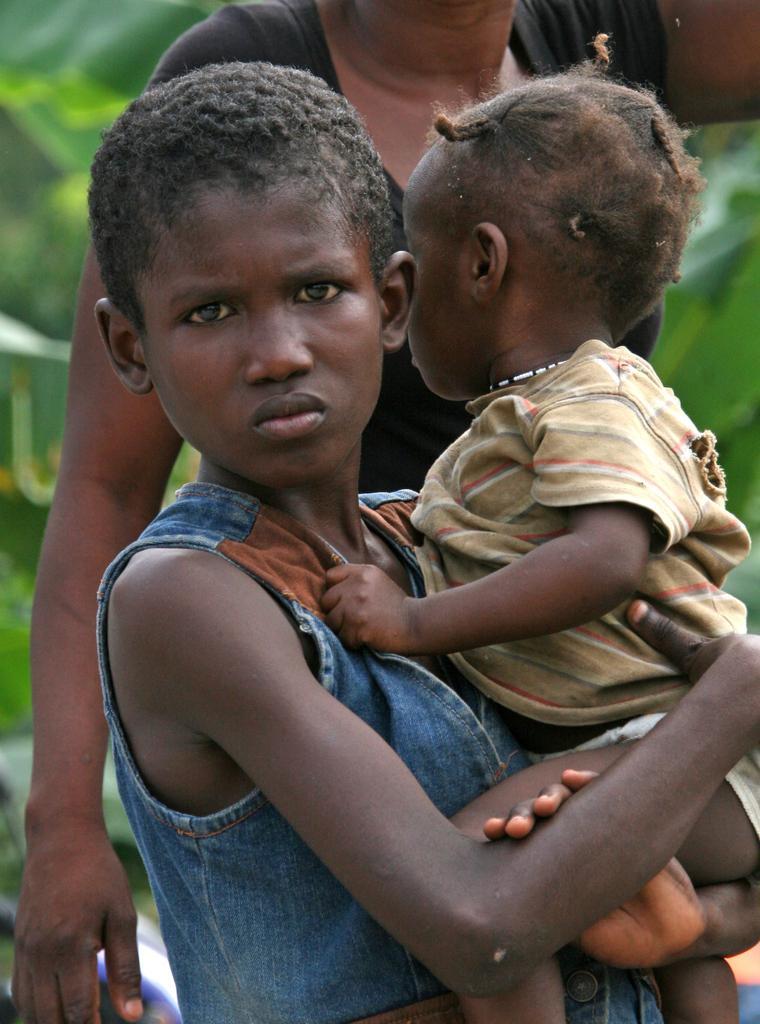Can you describe this image briefly? In this image I can see a person wearing blue and brown colored dress is standing and holding a baby. In the background I can see another person and few trees. 